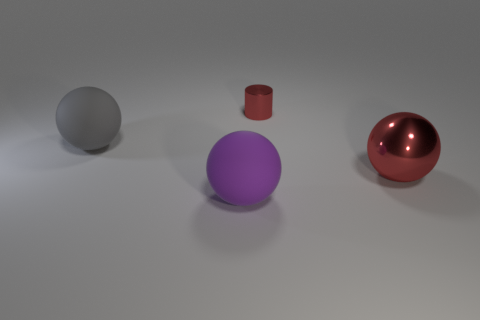Which objects in the image are spheres, and what are their colors? There are two spheres in the image. The one on the left is a muted grey, resembling a smooth pebble or a moon in the twilight. The one on the right reflects a vibrant red, reminiscent of a shiny apple or a holiday ornament. 